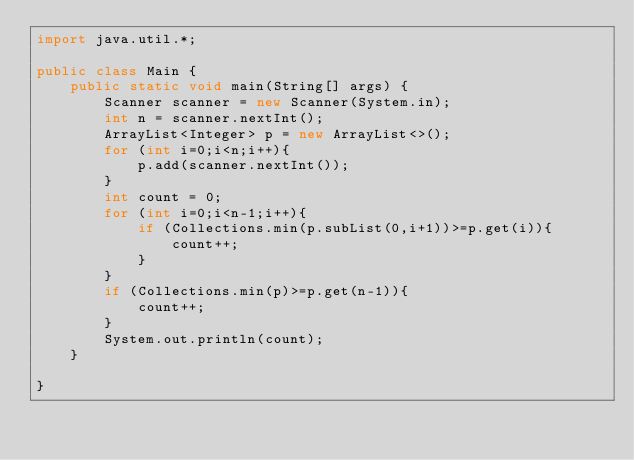Convert code to text. <code><loc_0><loc_0><loc_500><loc_500><_Java_>import java.util.*;

public class Main {
    public static void main(String[] args) {
        Scanner scanner = new Scanner(System.in);
        int n = scanner.nextInt();
        ArrayList<Integer> p = new ArrayList<>();
        for (int i=0;i<n;i++){
            p.add(scanner.nextInt());
        }
        int count = 0;
        for (int i=0;i<n-1;i++){
            if (Collections.min(p.subList(0,i+1))>=p.get(i)){
                count++;
            }
        }
        if (Collections.min(p)>=p.get(n-1)){
            count++;
        }
        System.out.println(count);
    }

}</code> 